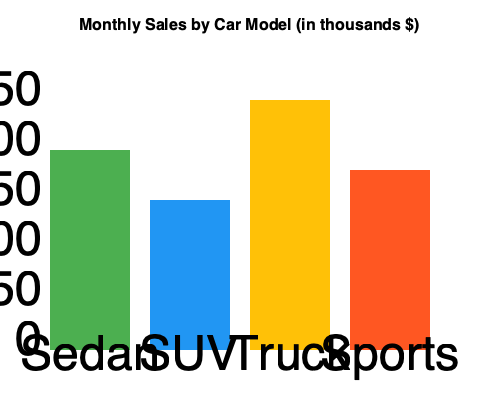As a car dealership owner, you understand the importance of profit margins. Given that the cost of parts for each car model is 70% of its sales price, which car model provides the highest profit margin based on the monthly sales data shown in the bar graph? To find the car model with the highest profit margin, we need to calculate the profit for each model and compare them. Let's go through this step-by-step:

1. Identify the sales figures for each model:
   Sedan: $200,000
   SUV: $150,000
   Truck: $250,000
   Sports: $180,000

2. Calculate the cost of parts (70% of sales price) for each model:
   Sedan: $200,000 × 0.70 = $140,000
   SUV: $150,000 × 0.70 = $105,000
   Truck: $250,000 × 0.70 = $175,000
   Sports: $180,000 × 0.70 = $126,000

3. Calculate the profit (sales price - cost of parts) for each model:
   Sedan: $200,000 - $140,000 = $60,000
   SUV: $150,000 - $105,000 = $45,000
   Truck: $250,000 - $175,000 = $75,000
   Sports: $180,000 - $126,000 = $54,000

4. Calculate the profit margin (profit ÷ sales price) for each model:
   Sedan: $60,000 ÷ $200,000 = 0.30 or 30%
   SUV: $45,000 ÷ $150,000 = 0.30 or 30%
   Truck: $75,000 ÷ $250,000 = 0.30 or 30%
   Sports: $54,000 ÷ $180,000 = 0.30 or 30%

5. Compare the profit margins:
   All car models have the same profit margin of 30%.

Therefore, all car models provide the same profit margin based on the given data.
Answer: All models have equal profit margins of 30%. 